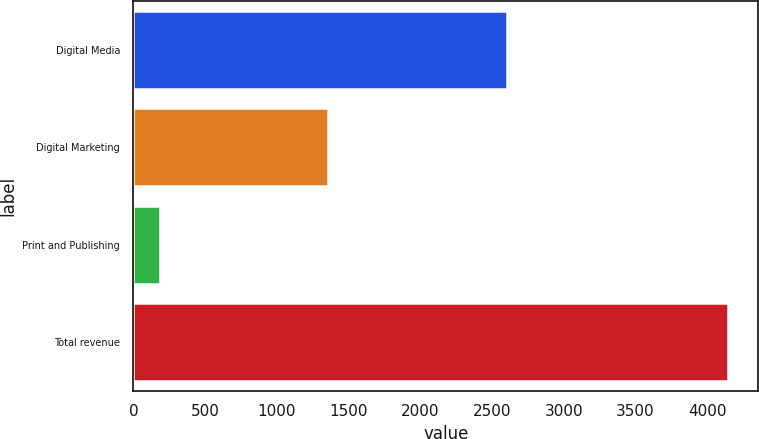Convert chart. <chart><loc_0><loc_0><loc_500><loc_500><bar_chart><fcel>Digital Media<fcel>Digital Marketing<fcel>Print and Publishing<fcel>Total revenue<nl><fcel>2603.2<fcel>1355.2<fcel>188.7<fcel>4147.1<nl></chart> 